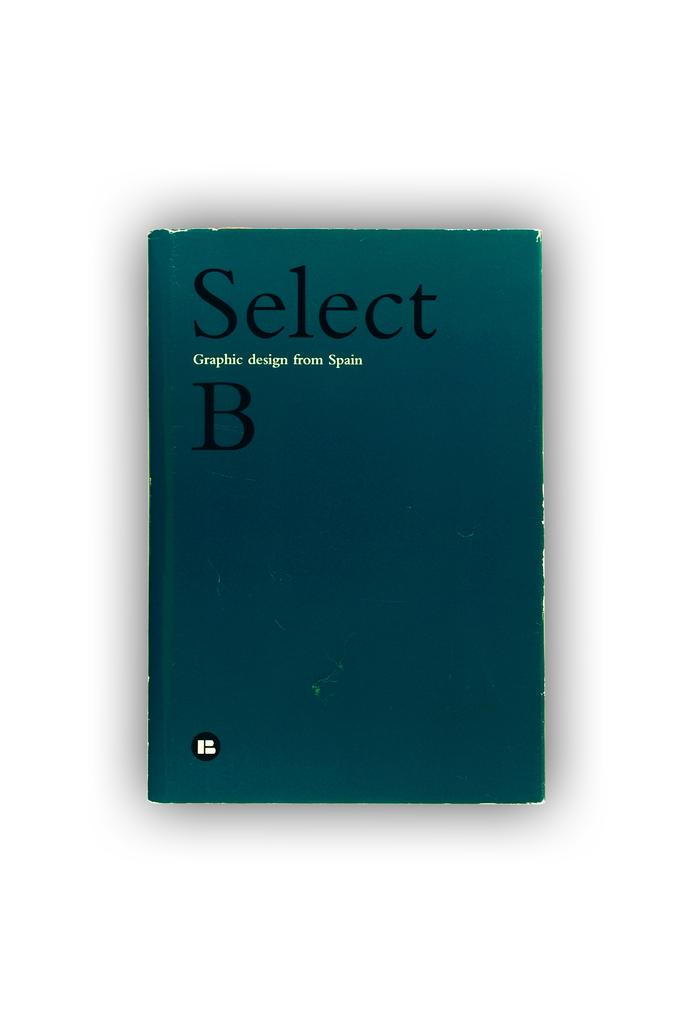<image>
Give a short and clear explanation of the subsequent image. A blue book sits against a white background titled Select B Graphic Design from Spain 